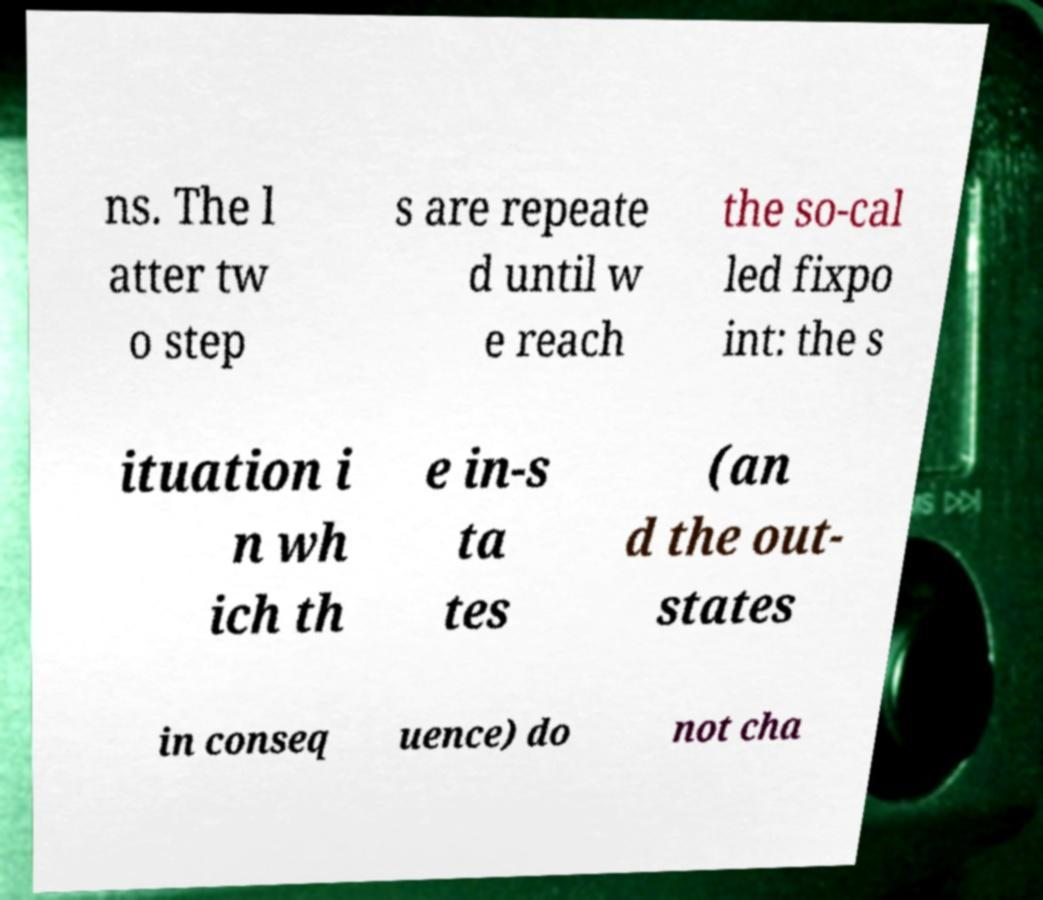What messages or text are displayed in this image? I need them in a readable, typed format. ns. The l atter tw o step s are repeate d until w e reach the so-cal led fixpo int: the s ituation i n wh ich th e in-s ta tes (an d the out- states in conseq uence) do not cha 